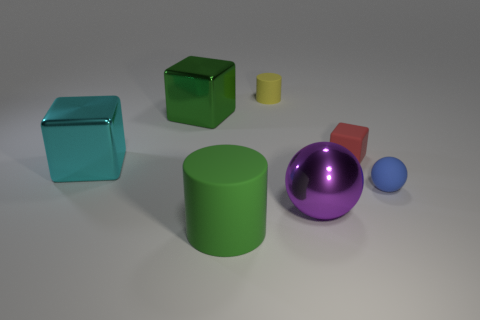What size is the metallic cube that is the same color as the big cylinder?
Keep it short and to the point. Large. What material is the yellow cylinder?
Make the answer very short. Rubber. Do the green object to the left of the large matte thing and the large sphere have the same material?
Provide a succinct answer. Yes. Are there fewer large cyan shiny things behind the tiny cube than blue matte spheres?
Offer a very short reply. Yes. What is the color of the matte cylinder that is the same size as the purple metal sphere?
Give a very brief answer. Green. What number of other large things have the same shape as the yellow object?
Your answer should be very brief. 1. What color is the cylinder behind the big purple metal object?
Give a very brief answer. Yellow. How many shiny things are tiny cubes or green cylinders?
Offer a very short reply. 0. What is the shape of the big metallic thing that is the same color as the big cylinder?
Your answer should be very brief. Cube. How many green matte cylinders are the same size as the purple metallic ball?
Your answer should be very brief. 1. 